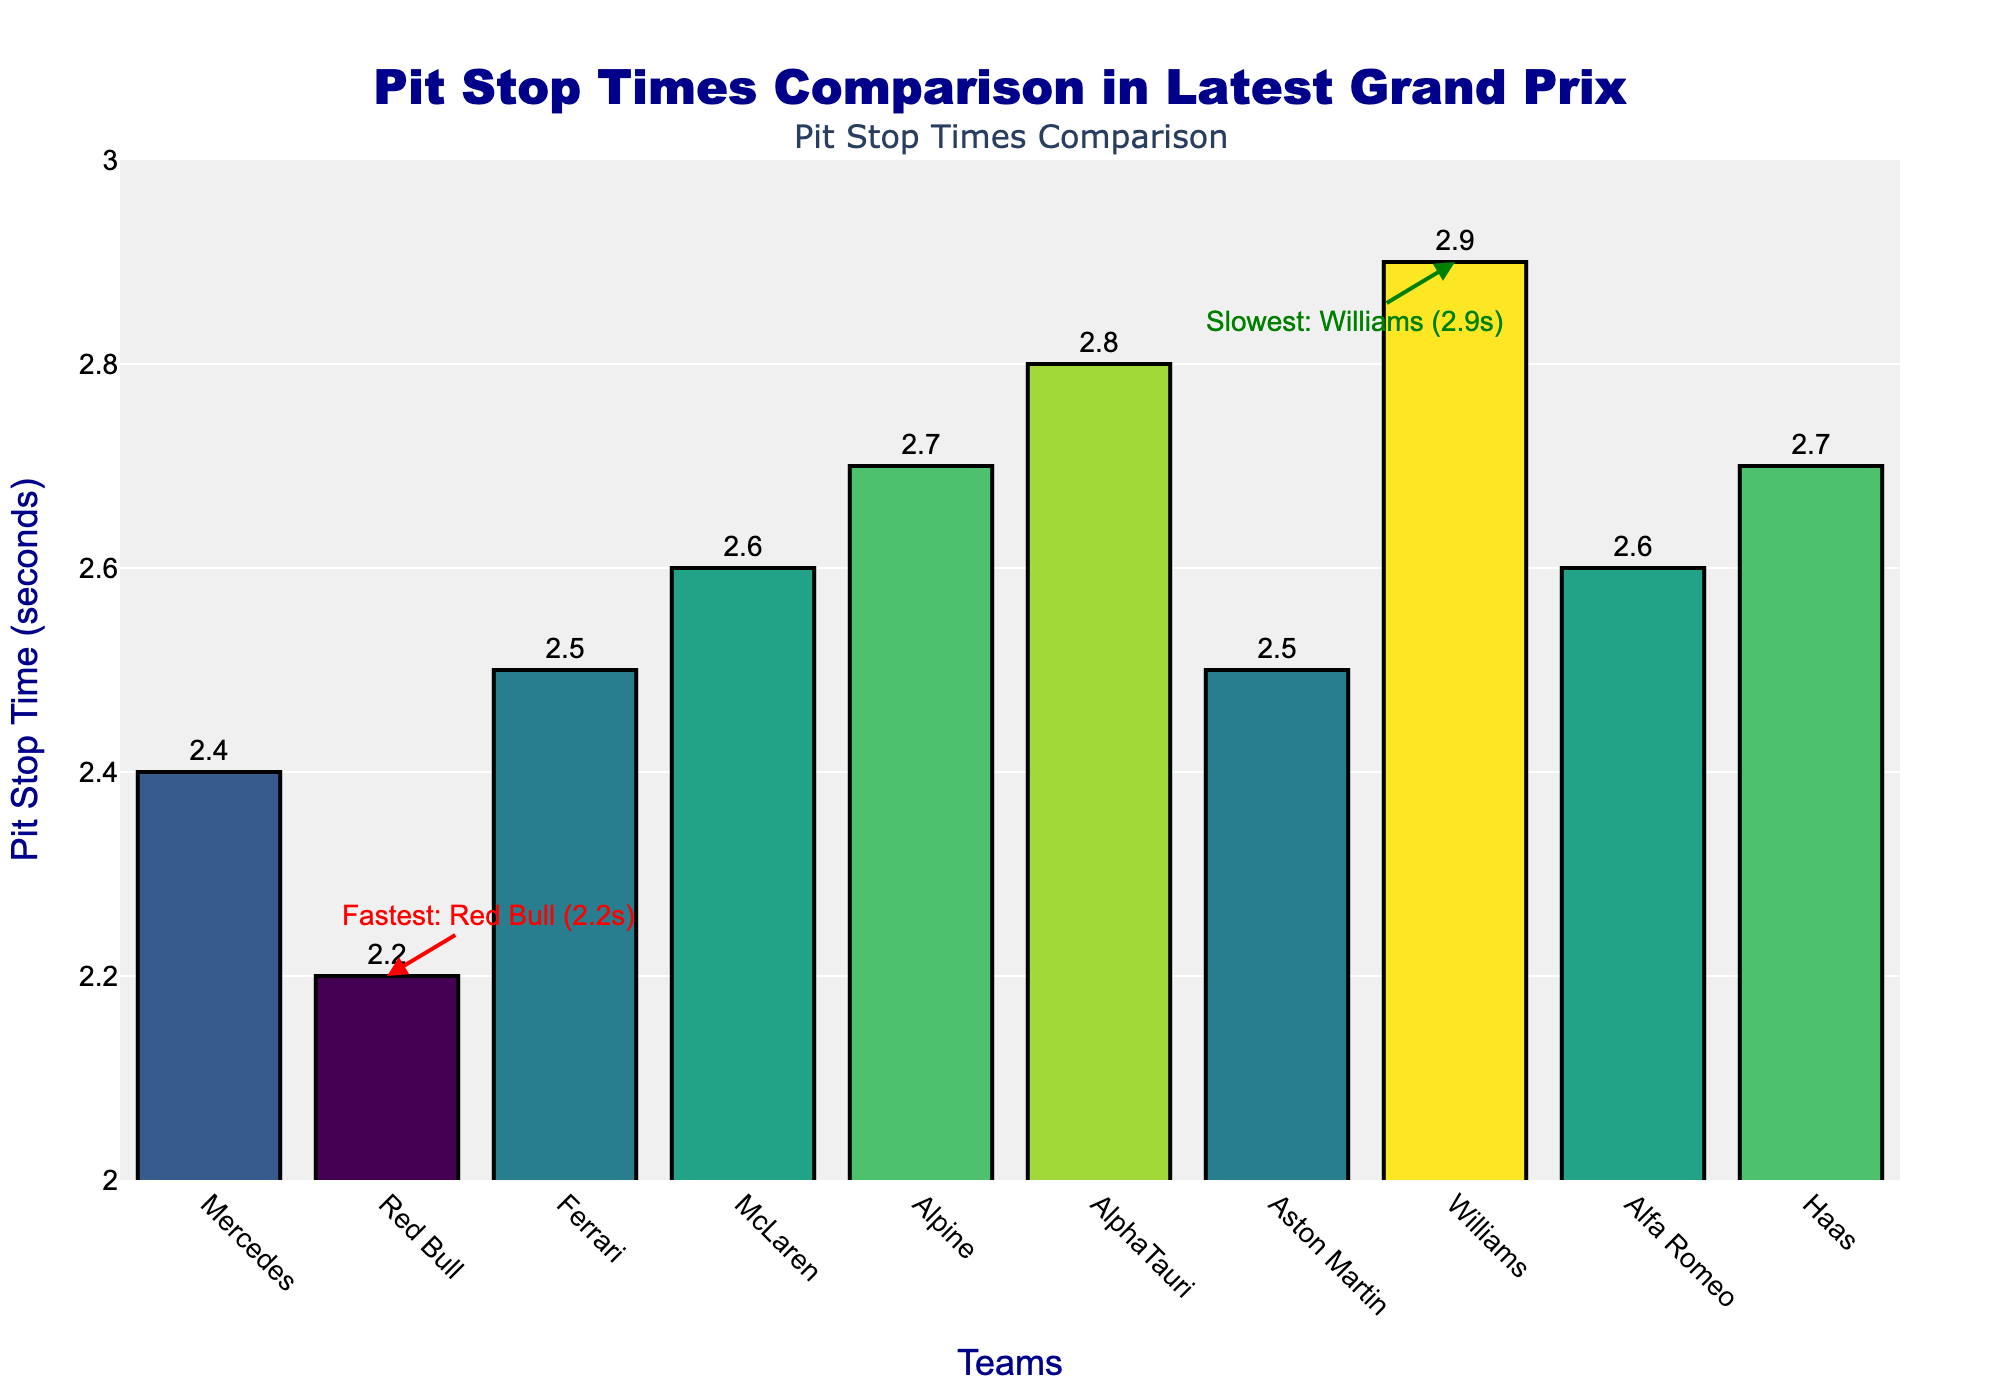Who had the fastest pit stop? We observe from the annotations and the heights of the bars that the fastest pit stop time is associated with Red Bull at 2.2 seconds.
Answer: Red Bull Which team had the slowest pit stop time? By referring to the annotations and the length of the bars, the team with the slowest pit stop time is Williams at 2.9 seconds.
Answer: Williams How much faster was Red Bull's pit stop compared to Ferrari's? From the chart, Red Bull recorded a pit stop time of 2.2 seconds and Ferrari recorded 2.5 seconds. The difference is calculated as 2.5 - 2.2 = 0.3 seconds.
Answer: 0.3 seconds Compare the pit stop times of McLaren and Alfa Romeo. Which one is faster? McLaren had a pit stop time of 2.6 seconds, and Alfa Romeo had a pit stop time of 2.6 seconds. Since both times are the same, neither is faster.
Answer: Both are equal What is the average pit stop time across all teams? To calculate the average, sum all pit stop times: (2.4 + 2.2 + 2.5 + 2.6 + 2.7 + 2.8 + 2.5 + 2.9 + 2.6 + 2.7) / 10 = 26.9 / 10 = 2.69 seconds.
Answer: 2.69 seconds What is the difference in pit stop times between Mercedes and Alpine? Mercedes had a pit stop time of 2.4 seconds, and Alpine had a pit stop time of 2.7 seconds. The difference is 2.7 - 2.4 = 0.3 seconds.
Answer: 0.3 seconds If we sort the teams by their pit stop times, which team is in the middle? Sorting the times gives: 2.2, 2.4, 2.5, 2.5, 2.6, 2.6, 2.7, 2.7, 2.8, 2.9. The teams in the middle are McLaren and Alfa Romeo with 2.6 seconds.
Answer: McLaren, Alfa Romeo Which teams had pit stop times greater than 2.5 seconds? Referring to the chart, the teams with times greater than 2.5 seconds are McLaren (2.6), Alpine (2.7), AlphaTauri (2.8), Williams (2.9), Alfa Romeo (2.6), and Haas (2.7).
Answer: McLaren, Alpine, AlphaTauri, Williams, Alfa Romeo, Haas 